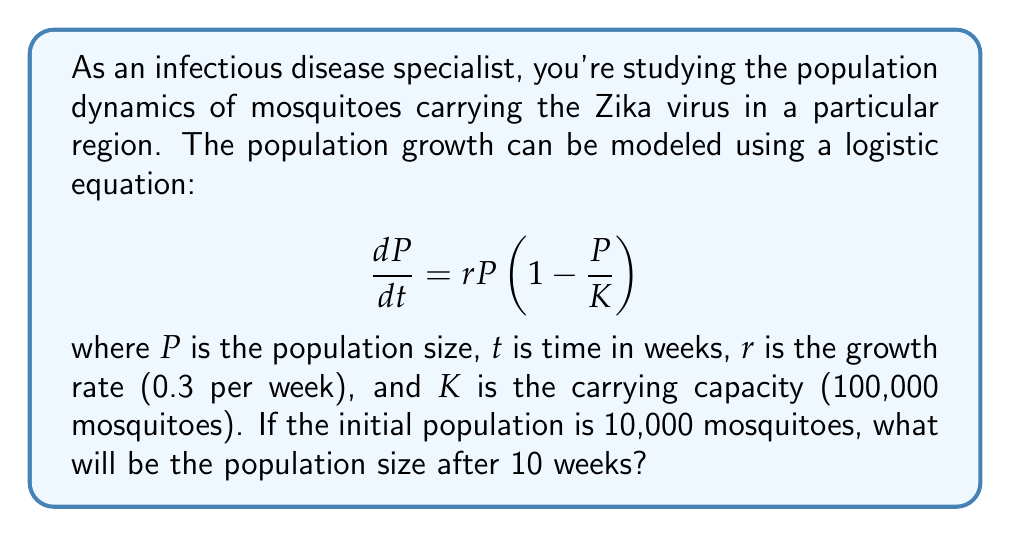Could you help me with this problem? To solve this problem, we need to use the solution to the logistic differential equation:

$$P(t) = \frac{K}{1 + \left(\frac{K}{P_0} - 1\right)e^{-rt}}$$

Where:
- $K = 100,000$ (carrying capacity)
- $P_0 = 10,000$ (initial population)
- $r = 0.3$ (growth rate per week)
- $t = 10$ (weeks)

Let's substitute these values into the equation:

$$P(10) = \frac{100,000}{1 + \left(\frac{100,000}{10,000} - 1\right)e^{-0.3 \cdot 10}}$$

$$= \frac{100,000}{1 + (9)e^{-3}}$$

Now, let's calculate $e^{-3}$:

$$e^{-3} \approx 0.0498$$

Substituting this back:

$$P(10) = \frac{100,000}{1 + 9 \cdot 0.0498}$$

$$= \frac{100,000}{1 + 0.4482}$$

$$= \frac{100,000}{1.4482}$$

$$\approx 69,051$$

Therefore, after 10 weeks, the mosquito population will be approximately 69,051.
Answer: 69,051 mosquitoes (rounded to the nearest whole number) 